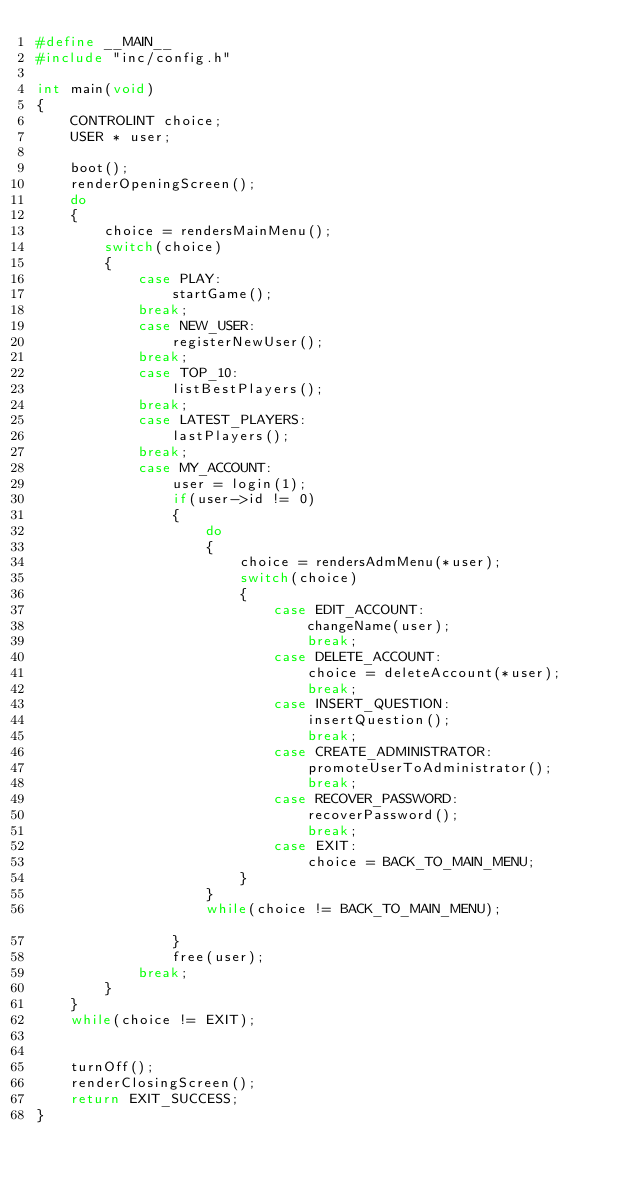Convert code to text. <code><loc_0><loc_0><loc_500><loc_500><_C_>#define __MAIN__
#include "inc/config.h"

int main(void) 
{	
	CONTROLINT choice;
	USER * user;
	
	boot();
	renderOpeningScreen();
	do
	{
		choice = rendersMainMenu();
		switch(choice)
		{
			case PLAY:
				startGame();
			break;
			case NEW_USER:
				registerNewUser();
			break;
			case TOP_10:
				listBestPlayers();
			break;
			case LATEST_PLAYERS:
				lastPlayers();
			break;
			case MY_ACCOUNT:
				user = login(1);
				if(user->id != 0)
				{
					do
					{
						choice = rendersAdmMenu(*user);
						switch(choice)
						{
							case EDIT_ACCOUNT:
								changeName(user);
								break;
							case DELETE_ACCOUNT:
								choice = deleteAccount(*user);
								break;
							case INSERT_QUESTION:
								insertQuestion();
								break;
							case CREATE_ADMINISTRATOR:
								promoteUserToAdministrator();
								break;
							case RECOVER_PASSWORD:
								recoverPassword();
								break;
							case EXIT:
								choice = BACK_TO_MAIN_MENU;
						}
					}
					while(choice != BACK_TO_MAIN_MENU);					
				}
				free(user);
			break;
		}
	}
	while(choice != EXIT);
	
	
	turnOff();
	renderClosingScreen();	
	return EXIT_SUCCESS;
}
</code> 